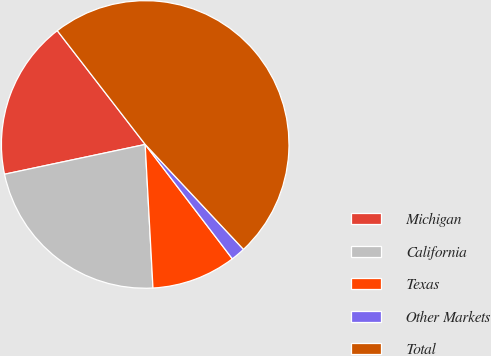Convert chart. <chart><loc_0><loc_0><loc_500><loc_500><pie_chart><fcel>Michigan<fcel>California<fcel>Texas<fcel>Other Markets<fcel>Total<nl><fcel>17.85%<fcel>22.54%<fcel>9.5%<fcel>1.62%<fcel>48.48%<nl></chart> 